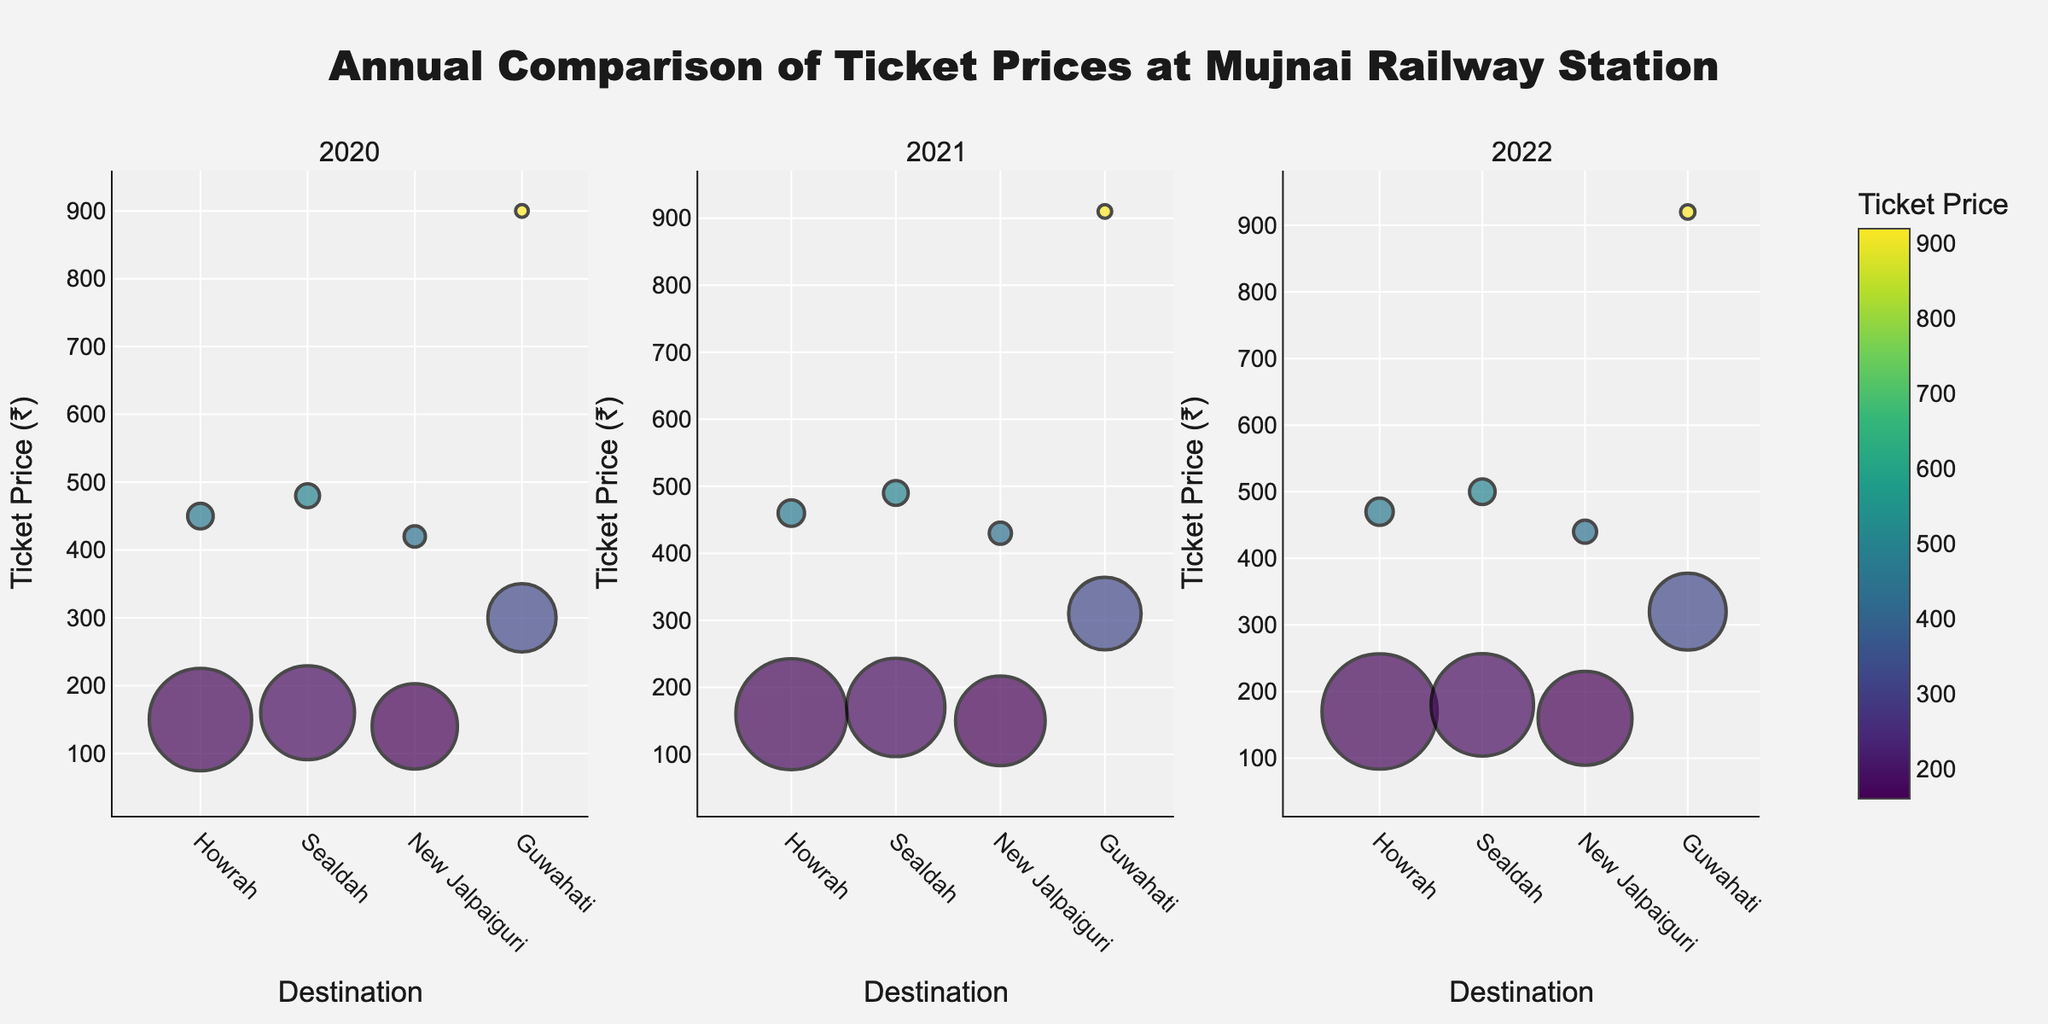What are the destinations shown in the plot for the year 2020? To identify the destinations, check the x-axis labels for the 2020 subplot. The destinations listed are 'Howrah', 'Sealdah', 'New Jalpaiguri', and 'Guwahati'.
Answer: Howrah, Sealdah, New Jalpaiguri, Guwahati Which destination had the highest ticket price in the year 2021? Look at the y-axis in the 2021 subplot for the highest bubble position. The highest ticket prices are found at 'Guwahati' with the First class ticket price of ₹910.
Answer: Guwahati What is the range of general class ticket prices in 2022? Observe the 2022 subplot. General class bubbles include prices for 'Howrah' ₹170, 'Sealdah' ₹180, 'New Jalpaiguri' ₹160, and 'Guwahati' ₹320. The range is calculated as ₹320 (max) - ₹160 (min).
Answer: ₹160 - ₹320 Which class has generally higher ticket prices, General or First Class? Compare the positions of the bubbles on the y-axis for both General and First classes across all subplots. First-class ticket prices are typically higher across all years and destinations.
Answer: First Class What is the average ticket price for Sealdah across all years? Collect all prices for Sealdah from the three subplots: ₹160 (2020), ₹170 (2021), ₹180 (2022) for General and ₹480 (2020), ₹490 (2021), ₹500 (2022) for First Class. Average these: (160+170+180+480+490+500)/6.
Answer: ₹330 How does the number of tickets sold in 2022 for Guwahati (General Class) compare to 2021? Compare the bubble sizes between the years 2022 and 2021 for General Class in Guwahati. In 2022, the number sold is 900, and in 2021 it is 850. The size difference suggests an increase.
Answer: Increased What is the median ticket price for Howrah in 2020 and 2021? List the ticket prices for both classes of Howrah in 2020 (₹150, ₹450) and 2021 (₹160, ₹460). The median for 2020 is (150+450)/2 and for 2021 is (160+460)/2.
Answer: ₹300, ₹310 Across all the years shown, which destination shows the smallest increase in General Class ticket price? Examine the vertical position changes of General Class bubbles for each destination across the subplots. Howrah: (2022 - 2020) = ₹170 - ₹150 = ₹20. Evaluate other destinations likewise to identify the smallest increment.
Answer: Howrah Which year had the highest ticket price for New Jalpaiguri (First Class)? Locate the highest position of the First Class bubble for New Jalpaiguri across the three subplots. The highest ticket price, ₹440, is in 2022.
Answer: 2022 